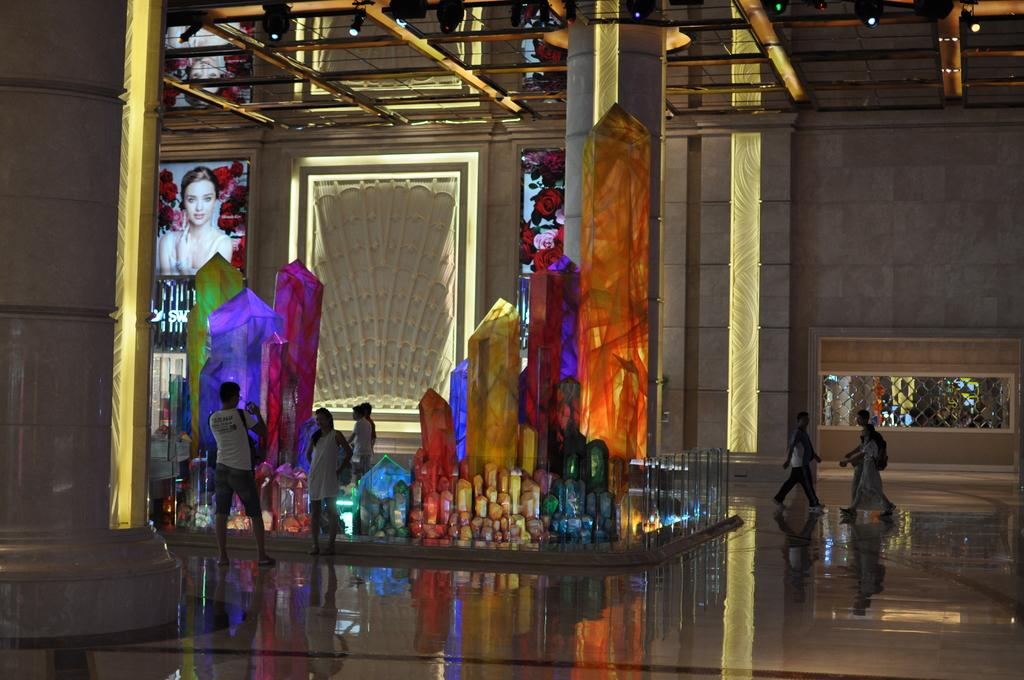What is happening on the surface in the image? There are people on the surface in the image. What can be seen on the roof in the image? There are light arrangements on the roof. What is present on the left side of the image? There is decoration on the left side of the image. What type of shoes are the people wearing in the image? There is no information about shoes in the image, as the focus is on the people, light arrangements, and decoration. What type of food can be seen in the image? There is no food present in the image. 